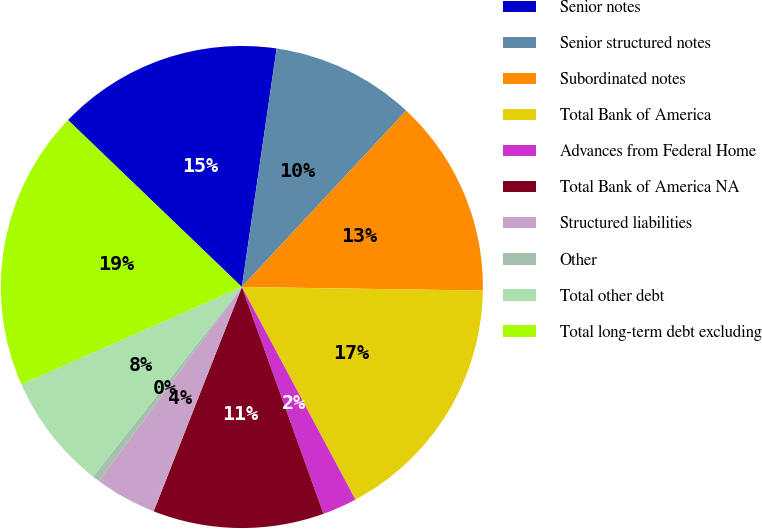Convert chart. <chart><loc_0><loc_0><loc_500><loc_500><pie_chart><fcel>Senior notes<fcel>Senior structured notes<fcel>Subordinated notes<fcel>Total Bank of America<fcel>Advances from Federal Home<fcel>Total Bank of America NA<fcel>Structured liabilities<fcel>Other<fcel>Total other debt<fcel>Total long-term debt excluding<nl><fcel>15.12%<fcel>9.63%<fcel>13.29%<fcel>16.95%<fcel>2.31%<fcel>11.46%<fcel>4.14%<fcel>0.48%<fcel>7.8%<fcel>18.78%<nl></chart> 